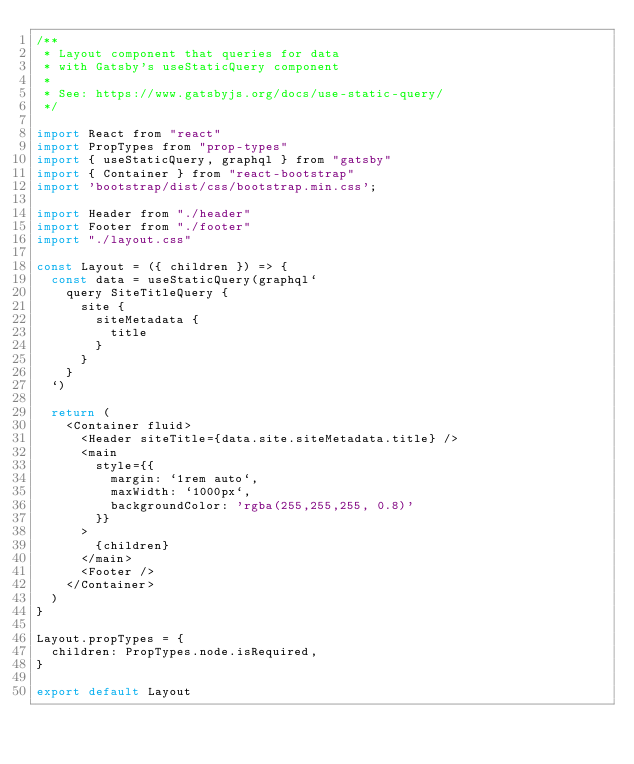<code> <loc_0><loc_0><loc_500><loc_500><_JavaScript_>/**
 * Layout component that queries for data
 * with Gatsby's useStaticQuery component
 *
 * See: https://www.gatsbyjs.org/docs/use-static-query/
 */

import React from "react"
import PropTypes from "prop-types"
import { useStaticQuery, graphql } from "gatsby"
import { Container } from "react-bootstrap"
import 'bootstrap/dist/css/bootstrap.min.css';

import Header from "./header"
import Footer from "./footer"
import "./layout.css"

const Layout = ({ children }) => {
  const data = useStaticQuery(graphql`
    query SiteTitleQuery {
      site {
        siteMetadata {
          title
        }
      }
    }
  `)

  return (
    <Container fluid>
      <Header siteTitle={data.site.siteMetadata.title} />
      <main
        style={{
          margin: `1rem auto`,
          maxWidth: `1000px`,
          backgroundColor: 'rgba(255,255,255, 0.8)'
        }}
      >
        {children}
      </main>
      <Footer />
    </Container>
  )
}

Layout.propTypes = {
  children: PropTypes.node.isRequired,
}

export default Layout
</code> 